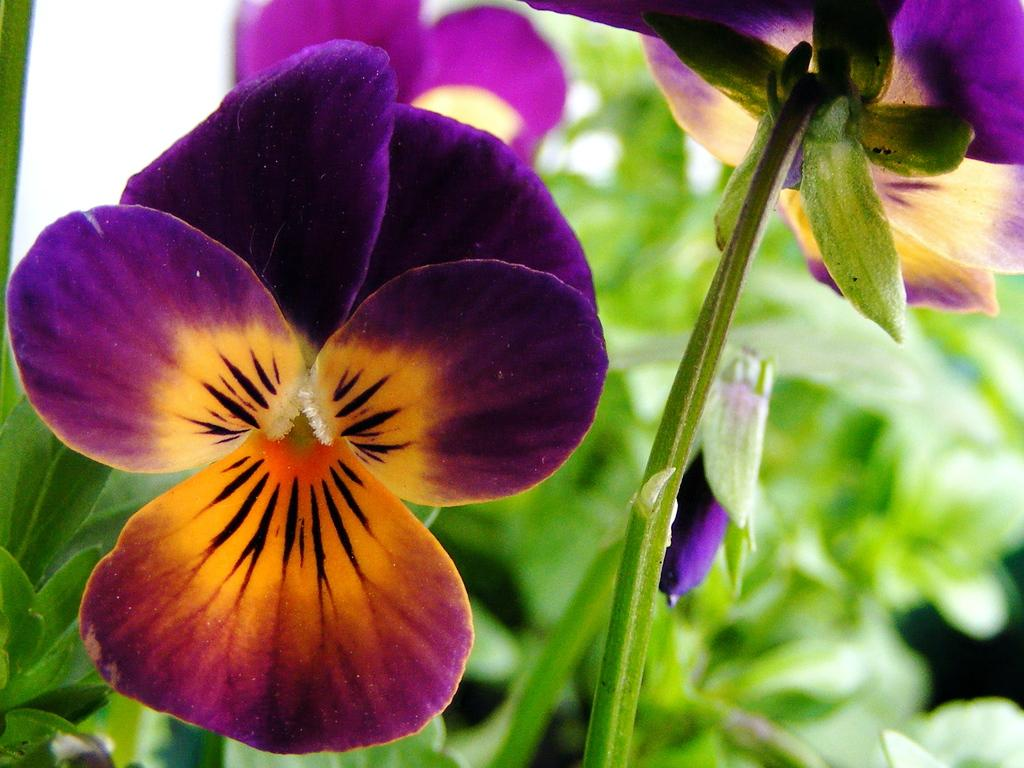What type of plant life is visible in the image? There are flowers, stems, and leaves in the image. Can you describe the structure of the plants in the image? The plants have flowers, stems, and leaves. What is the background of the image like? The background of the image is blurry. Who is the manager of the cabbage in the image? There is no cabbage or manager present in the image. 